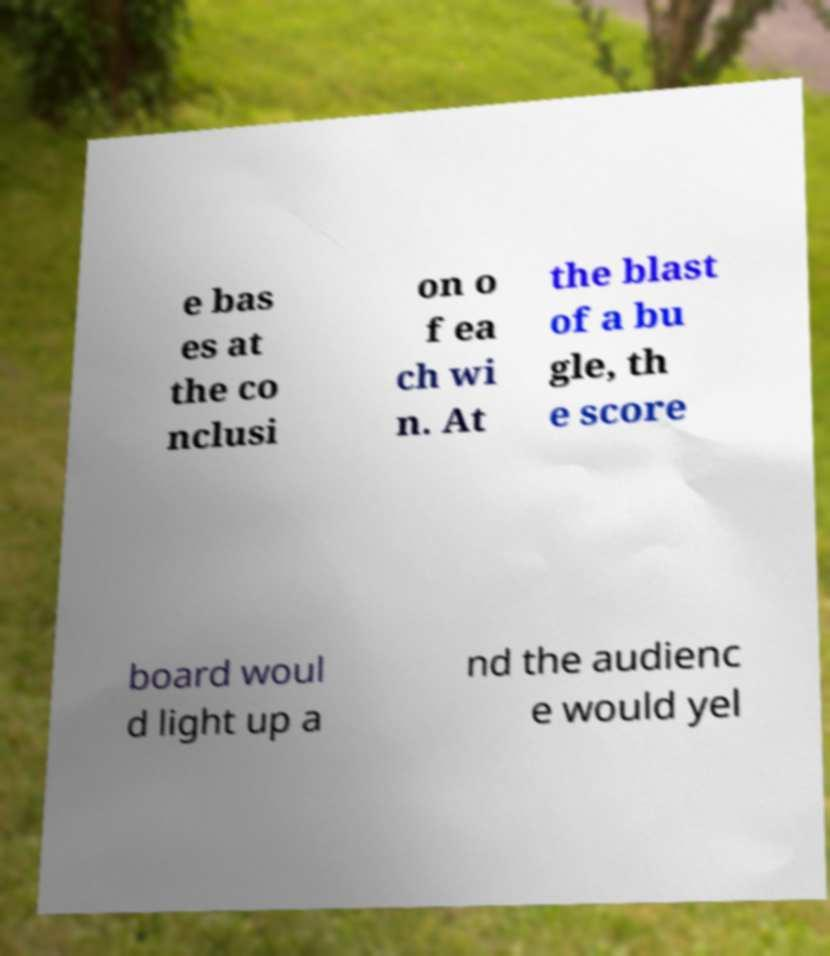Could you extract and type out the text from this image? e bas es at the co nclusi on o f ea ch wi n. At the blast of a bu gle, th e score board woul d light up a nd the audienc e would yel 